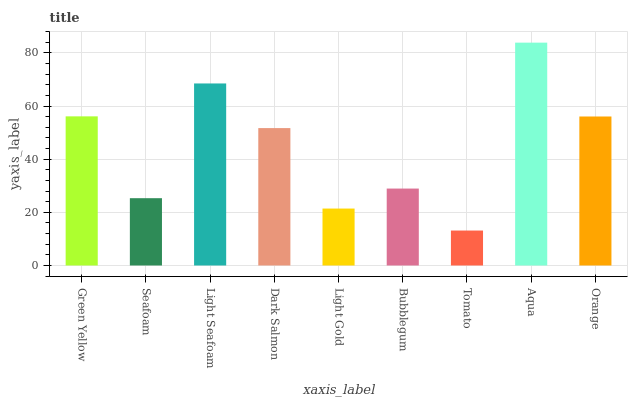Is Seafoam the minimum?
Answer yes or no. No. Is Seafoam the maximum?
Answer yes or no. No. Is Green Yellow greater than Seafoam?
Answer yes or no. Yes. Is Seafoam less than Green Yellow?
Answer yes or no. Yes. Is Seafoam greater than Green Yellow?
Answer yes or no. No. Is Green Yellow less than Seafoam?
Answer yes or no. No. Is Dark Salmon the high median?
Answer yes or no. Yes. Is Dark Salmon the low median?
Answer yes or no. Yes. Is Bubblegum the high median?
Answer yes or no. No. Is Light Gold the low median?
Answer yes or no. No. 